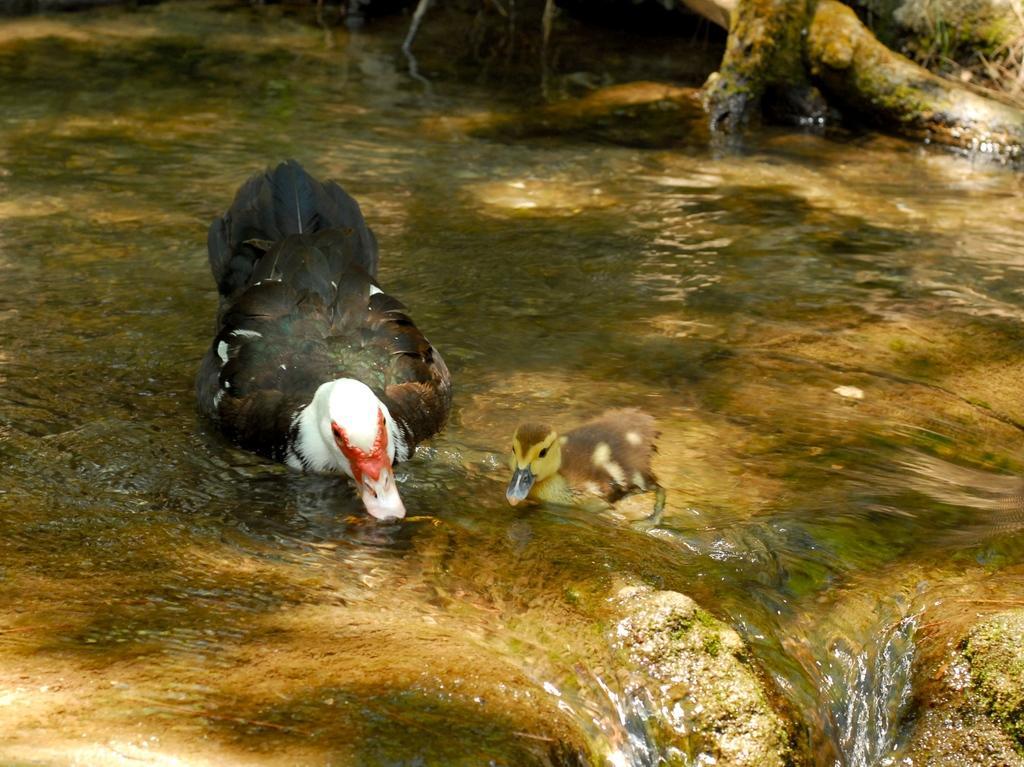Please provide a concise description of this image. In this image we can see the birds in the water, there is some wood and the grass. 